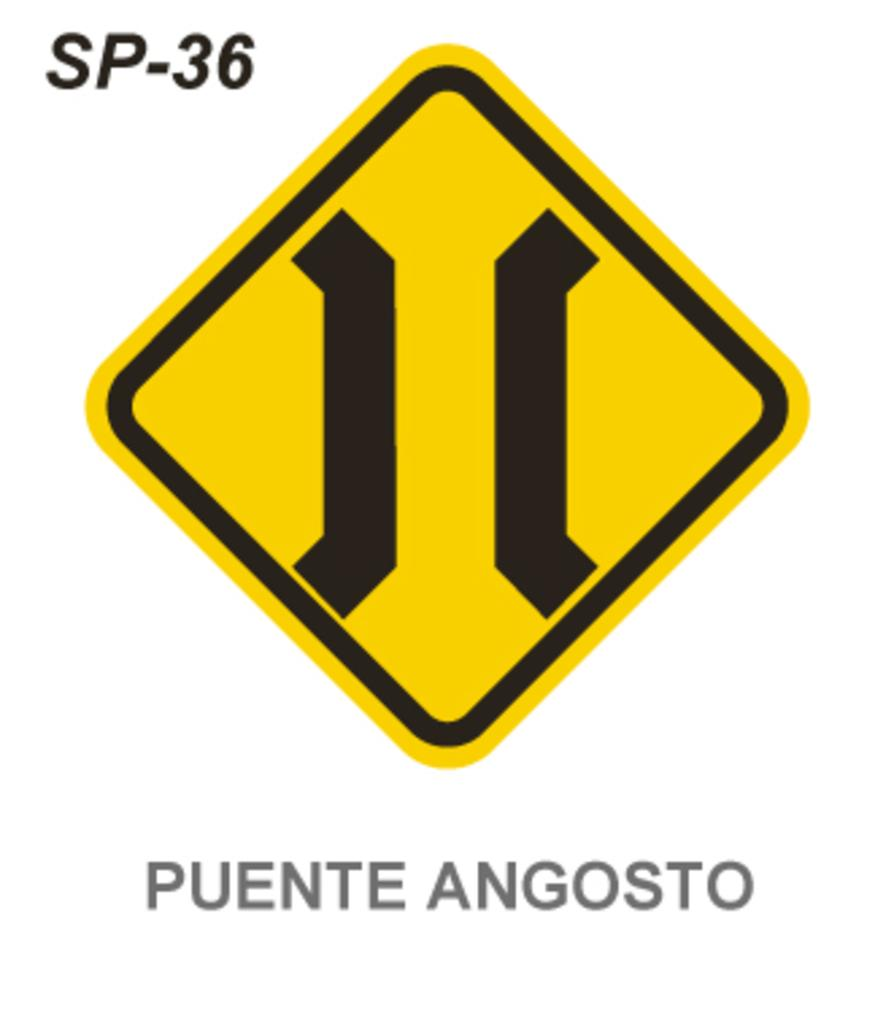<image>
Relay a brief, clear account of the picture shown. A yellow sign is in front of a white background and it says Puente Angosto beneath it. 